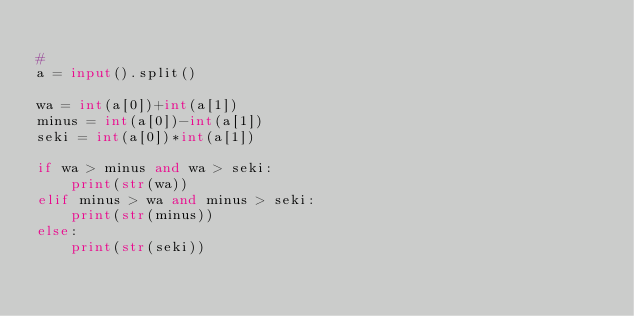<code> <loc_0><loc_0><loc_500><loc_500><_Python_>
#
a = input().split()

wa = int(a[0])+int(a[1])
minus = int(a[0])-int(a[1])
seki = int(a[0])*int(a[1])

if wa > minus and wa > seki:
    print(str(wa))
elif minus > wa and minus > seki:
    print(str(minus))
else:
    print(str(seki))
</code> 